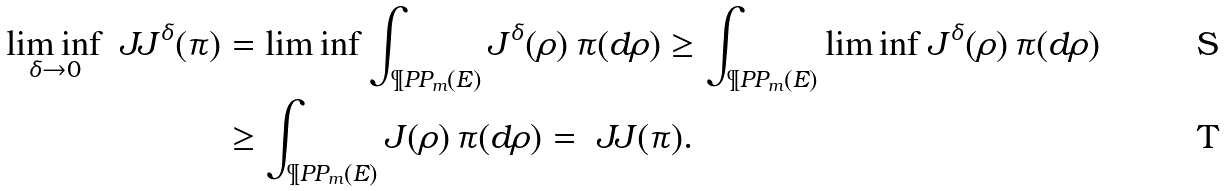Convert formula to latex. <formula><loc_0><loc_0><loc_500><loc_500>\liminf _ { \delta \to 0 } \ J J ^ { \delta } ( \pi ) & = \liminf \int _ { \P P P _ { m } ( E ) } J ^ { \delta } ( \rho ) \, \pi ( d \rho ) \geq \int _ { \P P P _ { m } ( E ) } \liminf J ^ { \delta } ( \rho ) \, \pi ( d \rho ) \\ & \geq \int _ { \P P P _ { m } ( E ) } J ( \rho ) \, \pi ( d \rho ) = \ J J ( \pi ) .</formula> 